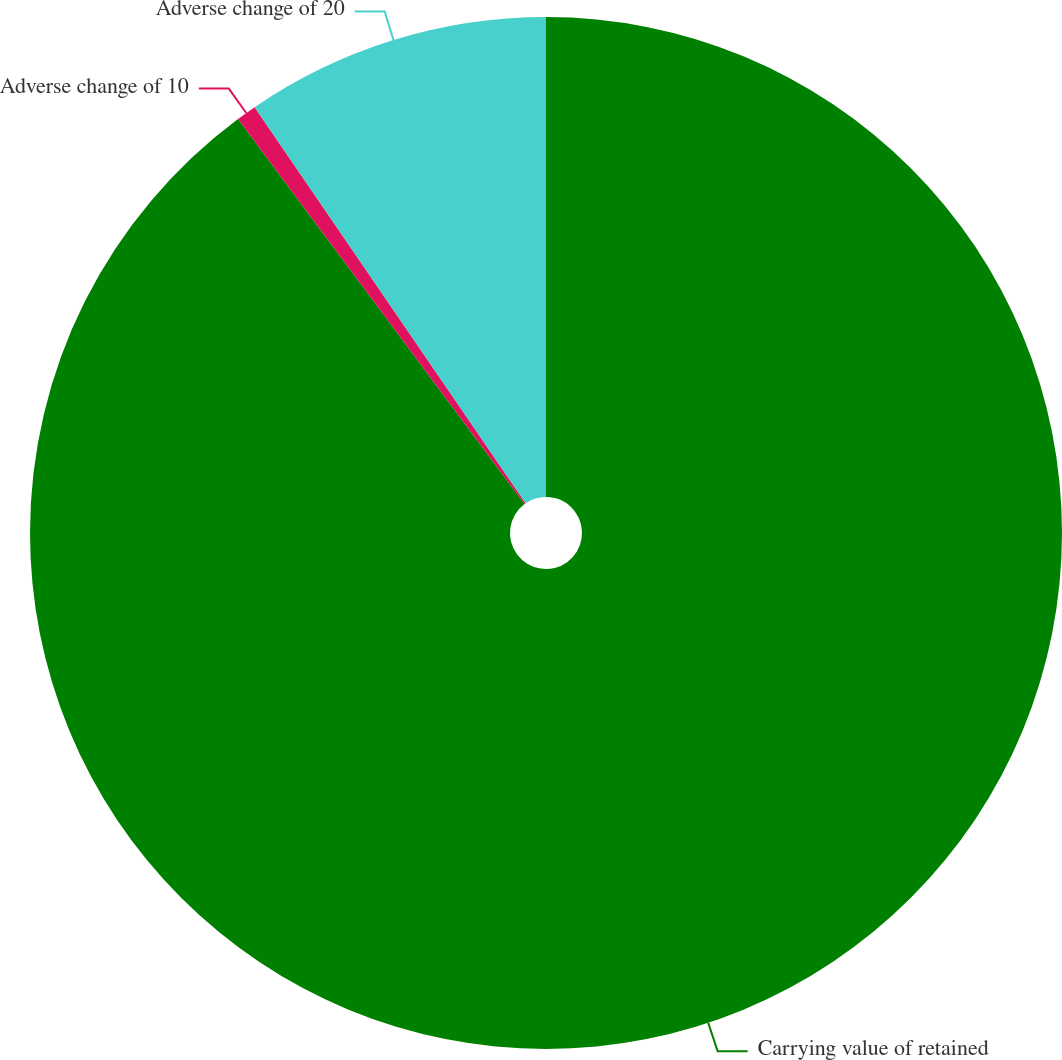Convert chart. <chart><loc_0><loc_0><loc_500><loc_500><pie_chart><fcel>Carrying value of retained<fcel>Adverse change of 10<fcel>Adverse change of 20<nl><fcel>89.82%<fcel>0.63%<fcel>9.55%<nl></chart> 